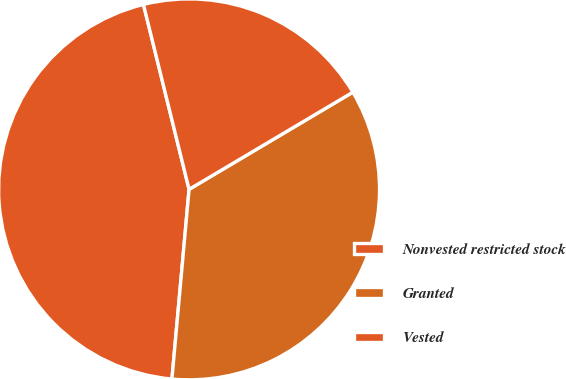Convert chart. <chart><loc_0><loc_0><loc_500><loc_500><pie_chart><fcel>Nonvested restricted stock<fcel>Granted<fcel>Vested<nl><fcel>44.72%<fcel>34.96%<fcel>20.33%<nl></chart> 